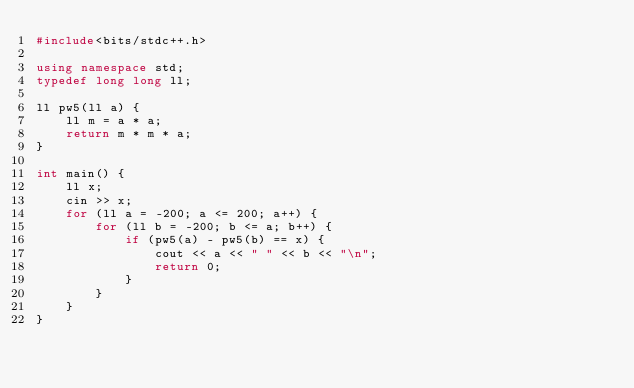Convert code to text. <code><loc_0><loc_0><loc_500><loc_500><_C++_>#include<bits/stdc++.h>

using namespace std;
typedef long long ll;

ll pw5(ll a) {
    ll m = a * a;
    return m * m * a;
}

int main() {
    ll x;
    cin >> x;
    for (ll a = -200; a <= 200; a++) {
        for (ll b = -200; b <= a; b++) {
            if (pw5(a) - pw5(b) == x) {
                cout << a << " " << b << "\n";
                return 0;
            }
        }
    }
}
</code> 